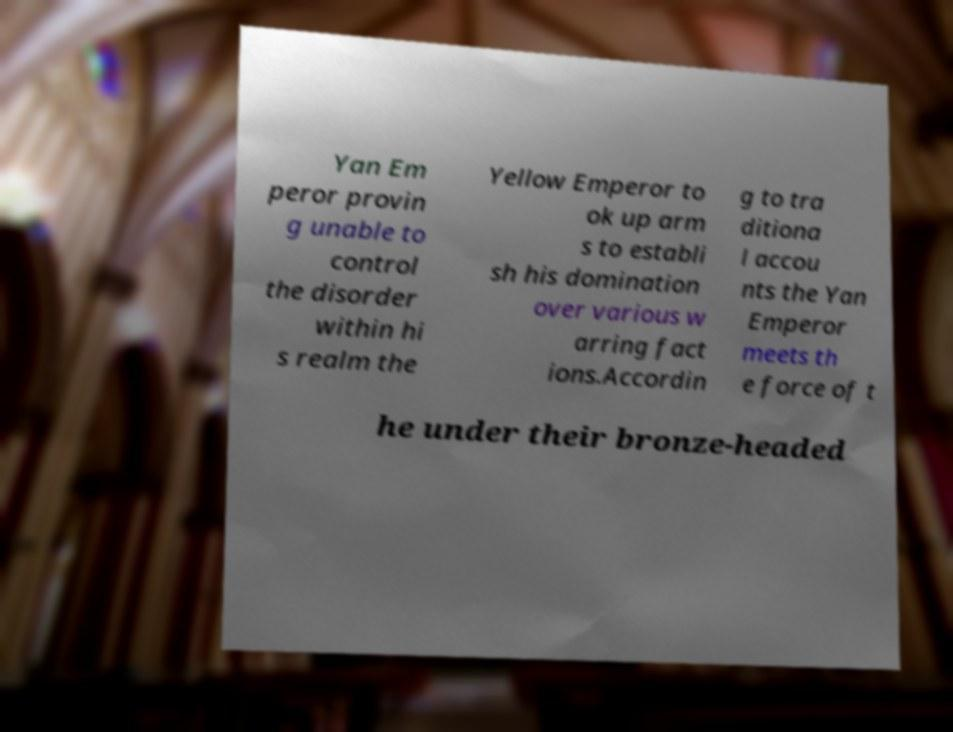There's text embedded in this image that I need extracted. Can you transcribe it verbatim? Yan Em peror provin g unable to control the disorder within hi s realm the Yellow Emperor to ok up arm s to establi sh his domination over various w arring fact ions.Accordin g to tra ditiona l accou nts the Yan Emperor meets th e force of t he under their bronze-headed 